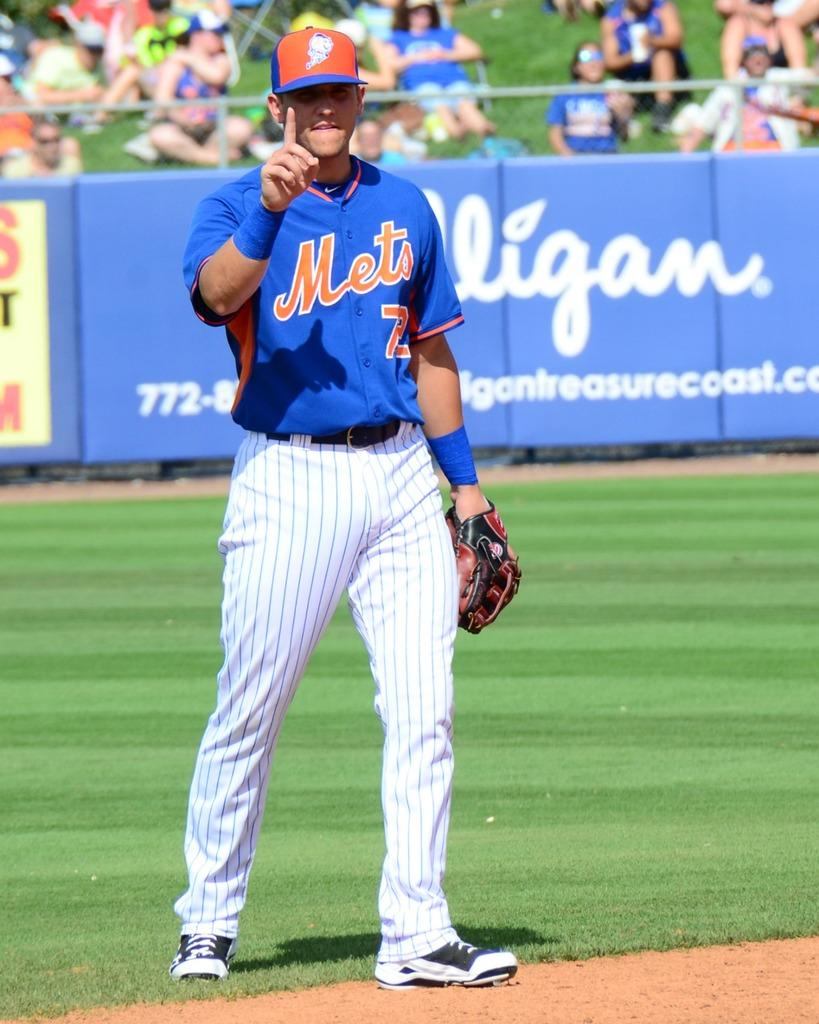Provide a one-sentence caption for the provided image. A Mets baseball player wearing blue jersey is holding up his no 1 finger with a smile. 